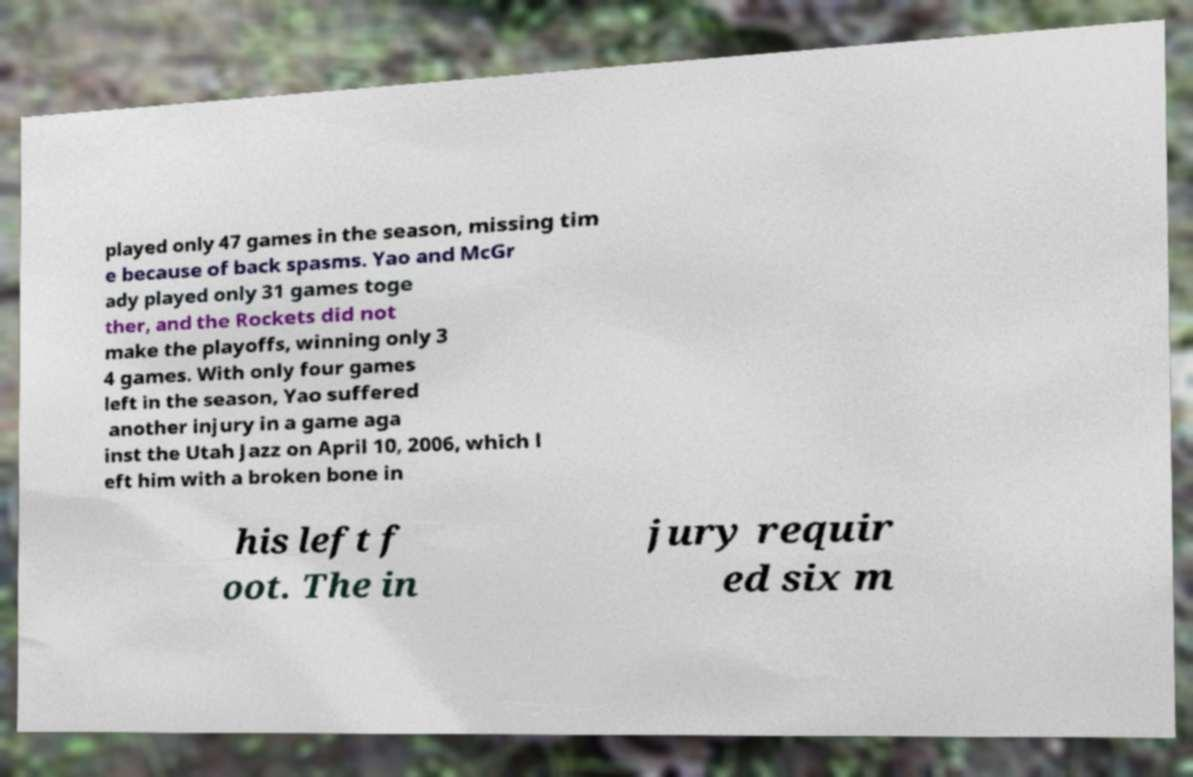I need the written content from this picture converted into text. Can you do that? played only 47 games in the season, missing tim e because of back spasms. Yao and McGr ady played only 31 games toge ther, and the Rockets did not make the playoffs, winning only 3 4 games. With only four games left in the season, Yao suffered another injury in a game aga inst the Utah Jazz on April 10, 2006, which l eft him with a broken bone in his left f oot. The in jury requir ed six m 